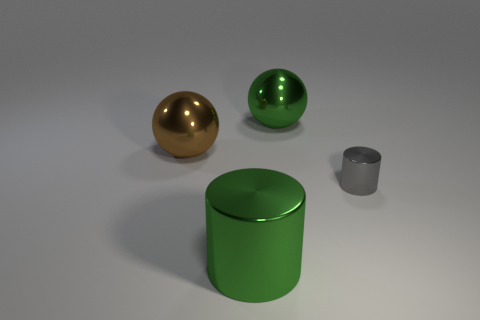How many matte objects are either brown objects or balls?
Provide a succinct answer. 0. What material is the sphere right of the metallic ball that is in front of the large green metal sphere?
Provide a short and direct response. Metal. The big cylinder is what color?
Keep it short and to the point. Green. There is a cylinder behind the large metallic cylinder; are there any large green cylinders that are to the right of it?
Your answer should be very brief. No. What is the material of the large green sphere?
Make the answer very short. Metal. Is there any other thing of the same color as the tiny shiny thing?
Your answer should be compact. No. What is the color of the big shiny object that is the same shape as the tiny object?
Offer a terse response. Green. There is a metal object that is both to the right of the large green shiny cylinder and in front of the brown thing; what size is it?
Keep it short and to the point. Small. Does the green object that is in front of the green metal sphere have the same shape as the large thing behind the large brown metal ball?
Keep it short and to the point. No. What number of other brown things have the same material as the brown thing?
Offer a terse response. 0. 